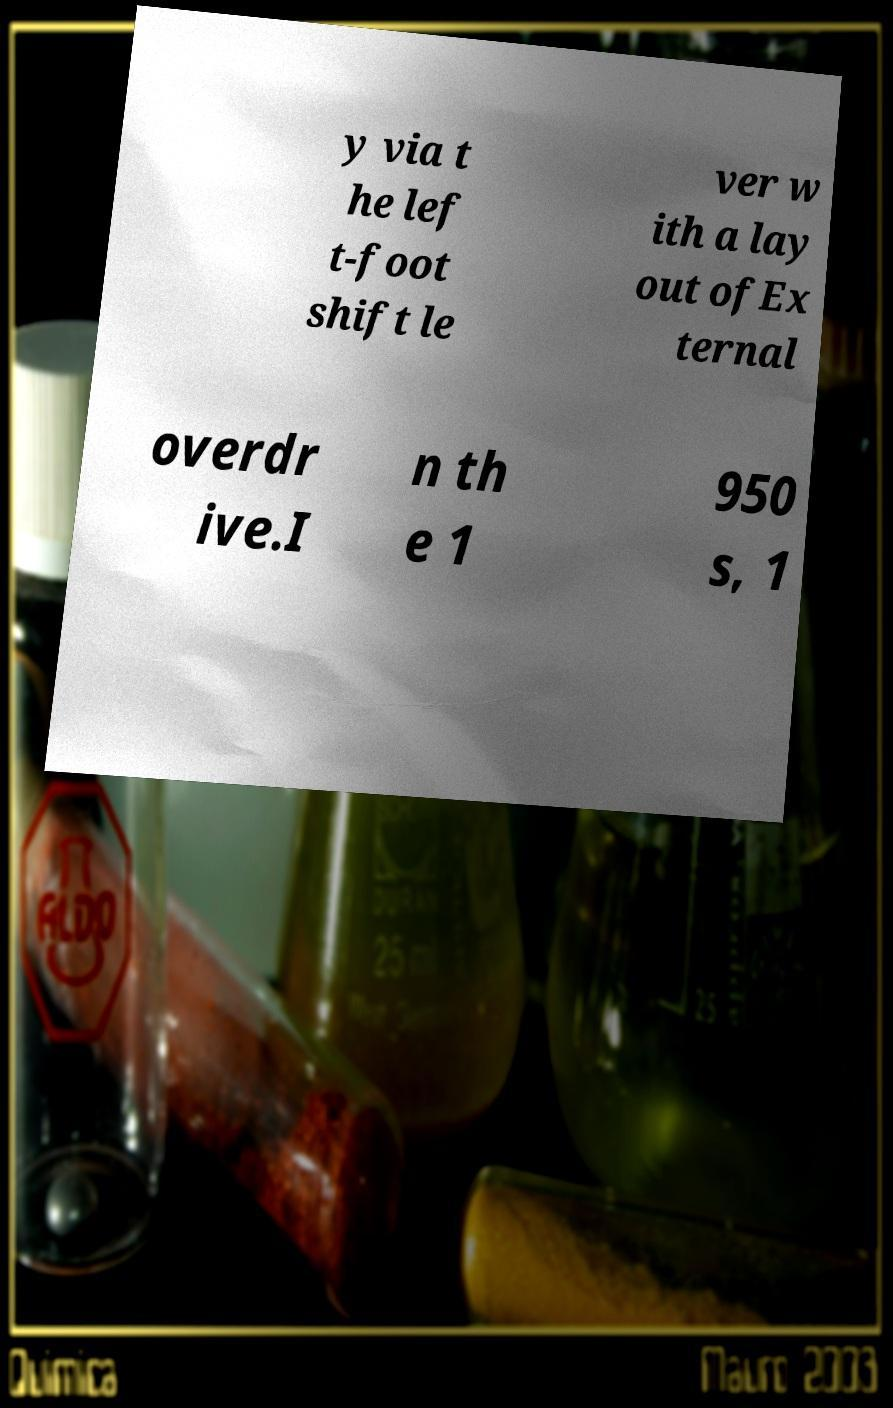Can you accurately transcribe the text from the provided image for me? y via t he lef t-foot shift le ver w ith a lay out ofEx ternal overdr ive.I n th e 1 950 s, 1 